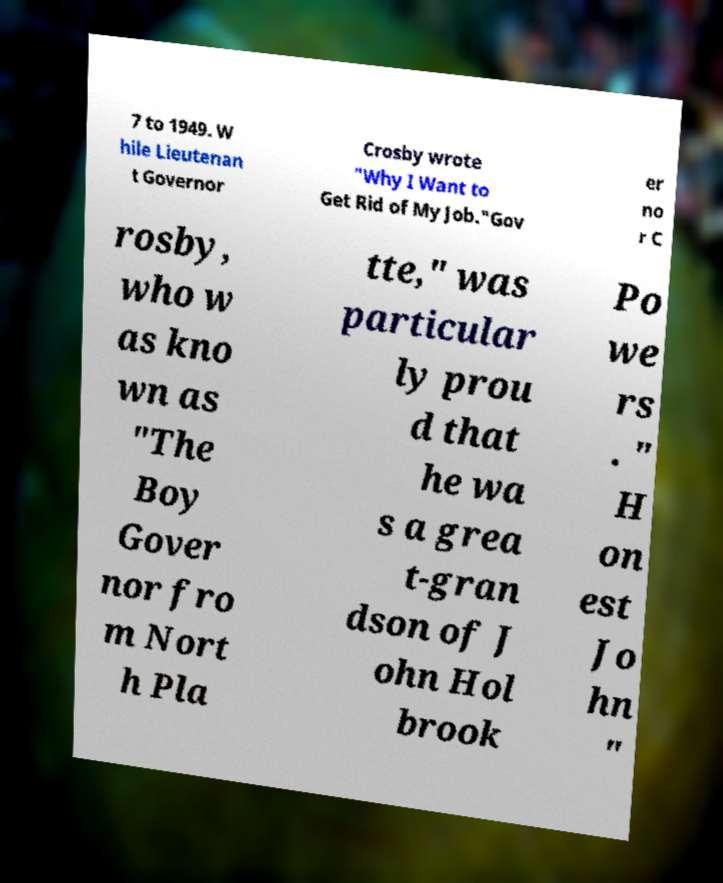Please identify and transcribe the text found in this image. 7 to 1949. W hile Lieutenan t Governor Crosby wrote "Why I Want to Get Rid of My Job."Gov er no r C rosby, who w as kno wn as "The Boy Gover nor fro m Nort h Pla tte," was particular ly prou d that he wa s a grea t-gran dson of J ohn Hol brook Po we rs . " H on est Jo hn " 